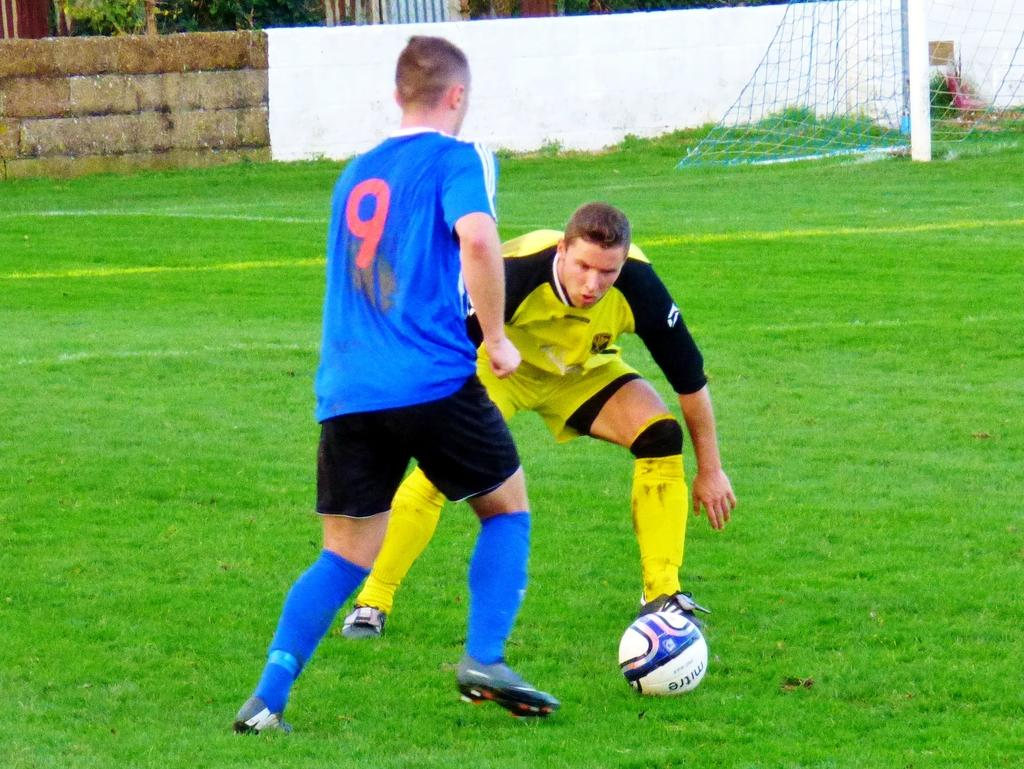What are the people in the image wearing? The people in the image are wearing T-shirts and shorts. What can be seen on the ground in the image? The ground in the image has some grass visible. What object is present in the image that is often used in sports? There is a ball in the image. What structure is present in the image that is often used in sports like tennis or volleyball? There is a net in the image. What architectural feature is present in the image? There is a wall in the image. What type of vegetation is present in the image? There are plants in the image. What type of map can be seen in the image? There is no map present in the image. How does the weather affect the people playing in the image? The provided facts do not mention any weather conditions, so we cannot determine how the weather might affect the people in the image. 